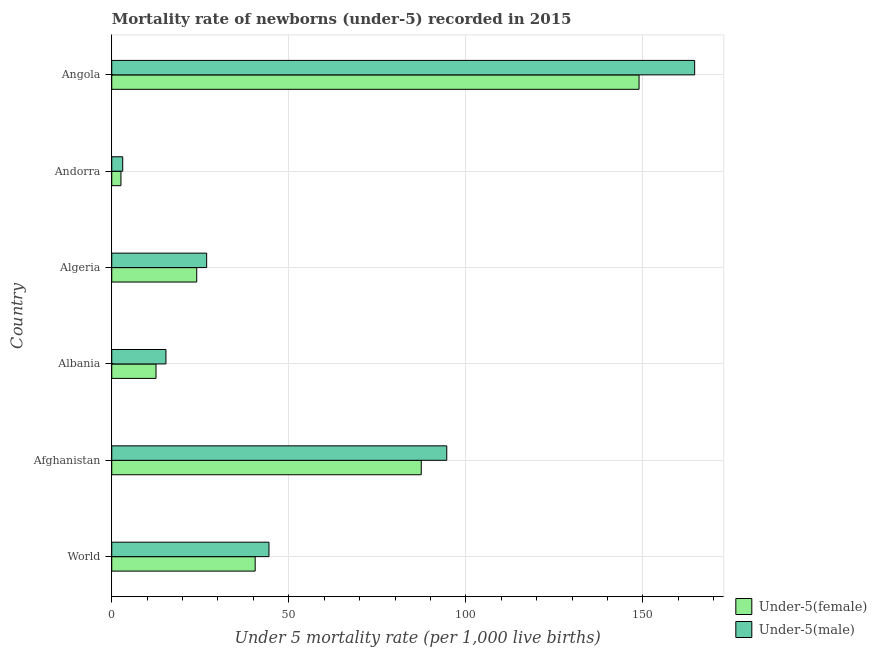Are the number of bars per tick equal to the number of legend labels?
Provide a short and direct response. Yes. Are the number of bars on each tick of the Y-axis equal?
Make the answer very short. Yes. What is the label of the 1st group of bars from the top?
Keep it short and to the point. Angola. Across all countries, what is the maximum under-5 male mortality rate?
Your response must be concise. 164.6. Across all countries, what is the minimum under-5 female mortality rate?
Your response must be concise. 2.6. In which country was the under-5 female mortality rate maximum?
Give a very brief answer. Angola. In which country was the under-5 male mortality rate minimum?
Offer a very short reply. Andorra. What is the total under-5 female mortality rate in the graph?
Give a very brief answer. 315.9. What is the difference between the under-5 female mortality rate in Afghanistan and that in Algeria?
Provide a short and direct response. 63.4. What is the difference between the under-5 male mortality rate in Andorra and the under-5 female mortality rate in Albania?
Your response must be concise. -9.4. What is the average under-5 male mortality rate per country?
Offer a very short reply. 58.13. What is the difference between the under-5 female mortality rate and under-5 male mortality rate in Angola?
Your answer should be very brief. -15.7. In how many countries, is the under-5 female mortality rate greater than 20 ?
Give a very brief answer. 4. What is the ratio of the under-5 male mortality rate in Albania to that in Angola?
Offer a terse response. 0.09. What is the difference between the highest and the second highest under-5 female mortality rate?
Make the answer very short. 61.5. What is the difference between the highest and the lowest under-5 female mortality rate?
Your answer should be compact. 146.3. What does the 1st bar from the top in Angola represents?
Your response must be concise. Under-5(male). What does the 2nd bar from the bottom in Afghanistan represents?
Keep it short and to the point. Under-5(male). Are the values on the major ticks of X-axis written in scientific E-notation?
Your response must be concise. No. Does the graph contain any zero values?
Make the answer very short. No. Does the graph contain grids?
Give a very brief answer. Yes. Where does the legend appear in the graph?
Offer a terse response. Bottom right. How are the legend labels stacked?
Keep it short and to the point. Vertical. What is the title of the graph?
Provide a succinct answer. Mortality rate of newborns (under-5) recorded in 2015. Does "Investment" appear as one of the legend labels in the graph?
Give a very brief answer. No. What is the label or title of the X-axis?
Keep it short and to the point. Under 5 mortality rate (per 1,0 live births). What is the Under 5 mortality rate (per 1,000 live births) in Under-5(female) in World?
Your answer should be very brief. 40.5. What is the Under 5 mortality rate (per 1,000 live births) in Under-5(male) in World?
Make the answer very short. 44.4. What is the Under 5 mortality rate (per 1,000 live births) of Under-5(female) in Afghanistan?
Provide a succinct answer. 87.4. What is the Under 5 mortality rate (per 1,000 live births) of Under-5(male) in Afghanistan?
Ensure brevity in your answer.  94.6. What is the Under 5 mortality rate (per 1,000 live births) of Under-5(female) in Algeria?
Your answer should be compact. 24. What is the Under 5 mortality rate (per 1,000 live births) of Under-5(male) in Algeria?
Your response must be concise. 26.8. What is the Under 5 mortality rate (per 1,000 live births) in Under-5(female) in Andorra?
Make the answer very short. 2.6. What is the Under 5 mortality rate (per 1,000 live births) in Under-5(male) in Andorra?
Give a very brief answer. 3.1. What is the Under 5 mortality rate (per 1,000 live births) of Under-5(female) in Angola?
Your answer should be compact. 148.9. What is the Under 5 mortality rate (per 1,000 live births) of Under-5(male) in Angola?
Make the answer very short. 164.6. Across all countries, what is the maximum Under 5 mortality rate (per 1,000 live births) of Under-5(female)?
Your answer should be very brief. 148.9. Across all countries, what is the maximum Under 5 mortality rate (per 1,000 live births) in Under-5(male)?
Your answer should be very brief. 164.6. Across all countries, what is the minimum Under 5 mortality rate (per 1,000 live births) of Under-5(female)?
Provide a short and direct response. 2.6. What is the total Under 5 mortality rate (per 1,000 live births) of Under-5(female) in the graph?
Make the answer very short. 315.9. What is the total Under 5 mortality rate (per 1,000 live births) in Under-5(male) in the graph?
Provide a short and direct response. 348.8. What is the difference between the Under 5 mortality rate (per 1,000 live births) of Under-5(female) in World and that in Afghanistan?
Give a very brief answer. -46.9. What is the difference between the Under 5 mortality rate (per 1,000 live births) in Under-5(male) in World and that in Afghanistan?
Make the answer very short. -50.2. What is the difference between the Under 5 mortality rate (per 1,000 live births) of Under-5(female) in World and that in Albania?
Ensure brevity in your answer.  28. What is the difference between the Under 5 mortality rate (per 1,000 live births) in Under-5(male) in World and that in Albania?
Your response must be concise. 29.1. What is the difference between the Under 5 mortality rate (per 1,000 live births) of Under-5(female) in World and that in Andorra?
Give a very brief answer. 37.9. What is the difference between the Under 5 mortality rate (per 1,000 live births) of Under-5(male) in World and that in Andorra?
Offer a very short reply. 41.3. What is the difference between the Under 5 mortality rate (per 1,000 live births) of Under-5(female) in World and that in Angola?
Offer a terse response. -108.4. What is the difference between the Under 5 mortality rate (per 1,000 live births) of Under-5(male) in World and that in Angola?
Keep it short and to the point. -120.2. What is the difference between the Under 5 mortality rate (per 1,000 live births) of Under-5(female) in Afghanistan and that in Albania?
Provide a short and direct response. 74.9. What is the difference between the Under 5 mortality rate (per 1,000 live births) in Under-5(male) in Afghanistan and that in Albania?
Keep it short and to the point. 79.3. What is the difference between the Under 5 mortality rate (per 1,000 live births) in Under-5(female) in Afghanistan and that in Algeria?
Ensure brevity in your answer.  63.4. What is the difference between the Under 5 mortality rate (per 1,000 live births) of Under-5(male) in Afghanistan and that in Algeria?
Provide a succinct answer. 67.8. What is the difference between the Under 5 mortality rate (per 1,000 live births) of Under-5(female) in Afghanistan and that in Andorra?
Offer a very short reply. 84.8. What is the difference between the Under 5 mortality rate (per 1,000 live births) in Under-5(male) in Afghanistan and that in Andorra?
Provide a short and direct response. 91.5. What is the difference between the Under 5 mortality rate (per 1,000 live births) in Under-5(female) in Afghanistan and that in Angola?
Give a very brief answer. -61.5. What is the difference between the Under 5 mortality rate (per 1,000 live births) of Under-5(male) in Afghanistan and that in Angola?
Your answer should be compact. -70. What is the difference between the Under 5 mortality rate (per 1,000 live births) of Under-5(female) in Albania and that in Andorra?
Your answer should be very brief. 9.9. What is the difference between the Under 5 mortality rate (per 1,000 live births) of Under-5(male) in Albania and that in Andorra?
Ensure brevity in your answer.  12.2. What is the difference between the Under 5 mortality rate (per 1,000 live births) in Under-5(female) in Albania and that in Angola?
Provide a succinct answer. -136.4. What is the difference between the Under 5 mortality rate (per 1,000 live births) of Under-5(male) in Albania and that in Angola?
Give a very brief answer. -149.3. What is the difference between the Under 5 mortality rate (per 1,000 live births) of Under-5(female) in Algeria and that in Andorra?
Your answer should be compact. 21.4. What is the difference between the Under 5 mortality rate (per 1,000 live births) of Under-5(male) in Algeria and that in Andorra?
Provide a succinct answer. 23.7. What is the difference between the Under 5 mortality rate (per 1,000 live births) in Under-5(female) in Algeria and that in Angola?
Your answer should be very brief. -124.9. What is the difference between the Under 5 mortality rate (per 1,000 live births) in Under-5(male) in Algeria and that in Angola?
Give a very brief answer. -137.8. What is the difference between the Under 5 mortality rate (per 1,000 live births) in Under-5(female) in Andorra and that in Angola?
Provide a short and direct response. -146.3. What is the difference between the Under 5 mortality rate (per 1,000 live births) in Under-5(male) in Andorra and that in Angola?
Give a very brief answer. -161.5. What is the difference between the Under 5 mortality rate (per 1,000 live births) in Under-5(female) in World and the Under 5 mortality rate (per 1,000 live births) in Under-5(male) in Afghanistan?
Your response must be concise. -54.1. What is the difference between the Under 5 mortality rate (per 1,000 live births) in Under-5(female) in World and the Under 5 mortality rate (per 1,000 live births) in Under-5(male) in Albania?
Keep it short and to the point. 25.2. What is the difference between the Under 5 mortality rate (per 1,000 live births) in Under-5(female) in World and the Under 5 mortality rate (per 1,000 live births) in Under-5(male) in Algeria?
Make the answer very short. 13.7. What is the difference between the Under 5 mortality rate (per 1,000 live births) in Under-5(female) in World and the Under 5 mortality rate (per 1,000 live births) in Under-5(male) in Andorra?
Provide a succinct answer. 37.4. What is the difference between the Under 5 mortality rate (per 1,000 live births) in Under-5(female) in World and the Under 5 mortality rate (per 1,000 live births) in Under-5(male) in Angola?
Provide a succinct answer. -124.1. What is the difference between the Under 5 mortality rate (per 1,000 live births) in Under-5(female) in Afghanistan and the Under 5 mortality rate (per 1,000 live births) in Under-5(male) in Albania?
Keep it short and to the point. 72.1. What is the difference between the Under 5 mortality rate (per 1,000 live births) of Under-5(female) in Afghanistan and the Under 5 mortality rate (per 1,000 live births) of Under-5(male) in Algeria?
Provide a succinct answer. 60.6. What is the difference between the Under 5 mortality rate (per 1,000 live births) in Under-5(female) in Afghanistan and the Under 5 mortality rate (per 1,000 live births) in Under-5(male) in Andorra?
Ensure brevity in your answer.  84.3. What is the difference between the Under 5 mortality rate (per 1,000 live births) of Under-5(female) in Afghanistan and the Under 5 mortality rate (per 1,000 live births) of Under-5(male) in Angola?
Give a very brief answer. -77.2. What is the difference between the Under 5 mortality rate (per 1,000 live births) in Under-5(female) in Albania and the Under 5 mortality rate (per 1,000 live births) in Under-5(male) in Algeria?
Your response must be concise. -14.3. What is the difference between the Under 5 mortality rate (per 1,000 live births) in Under-5(female) in Albania and the Under 5 mortality rate (per 1,000 live births) in Under-5(male) in Angola?
Your answer should be very brief. -152.1. What is the difference between the Under 5 mortality rate (per 1,000 live births) of Under-5(female) in Algeria and the Under 5 mortality rate (per 1,000 live births) of Under-5(male) in Andorra?
Provide a succinct answer. 20.9. What is the difference between the Under 5 mortality rate (per 1,000 live births) of Under-5(female) in Algeria and the Under 5 mortality rate (per 1,000 live births) of Under-5(male) in Angola?
Your response must be concise. -140.6. What is the difference between the Under 5 mortality rate (per 1,000 live births) of Under-5(female) in Andorra and the Under 5 mortality rate (per 1,000 live births) of Under-5(male) in Angola?
Give a very brief answer. -162. What is the average Under 5 mortality rate (per 1,000 live births) of Under-5(female) per country?
Offer a very short reply. 52.65. What is the average Under 5 mortality rate (per 1,000 live births) of Under-5(male) per country?
Make the answer very short. 58.13. What is the difference between the Under 5 mortality rate (per 1,000 live births) in Under-5(female) and Under 5 mortality rate (per 1,000 live births) in Under-5(male) in World?
Offer a very short reply. -3.9. What is the difference between the Under 5 mortality rate (per 1,000 live births) of Under-5(female) and Under 5 mortality rate (per 1,000 live births) of Under-5(male) in Afghanistan?
Offer a very short reply. -7.2. What is the difference between the Under 5 mortality rate (per 1,000 live births) of Under-5(female) and Under 5 mortality rate (per 1,000 live births) of Under-5(male) in Algeria?
Make the answer very short. -2.8. What is the difference between the Under 5 mortality rate (per 1,000 live births) in Under-5(female) and Under 5 mortality rate (per 1,000 live births) in Under-5(male) in Angola?
Your response must be concise. -15.7. What is the ratio of the Under 5 mortality rate (per 1,000 live births) in Under-5(female) in World to that in Afghanistan?
Keep it short and to the point. 0.46. What is the ratio of the Under 5 mortality rate (per 1,000 live births) of Under-5(male) in World to that in Afghanistan?
Offer a terse response. 0.47. What is the ratio of the Under 5 mortality rate (per 1,000 live births) in Under-5(female) in World to that in Albania?
Your answer should be very brief. 3.24. What is the ratio of the Under 5 mortality rate (per 1,000 live births) of Under-5(male) in World to that in Albania?
Offer a very short reply. 2.9. What is the ratio of the Under 5 mortality rate (per 1,000 live births) of Under-5(female) in World to that in Algeria?
Provide a short and direct response. 1.69. What is the ratio of the Under 5 mortality rate (per 1,000 live births) in Under-5(male) in World to that in Algeria?
Ensure brevity in your answer.  1.66. What is the ratio of the Under 5 mortality rate (per 1,000 live births) of Under-5(female) in World to that in Andorra?
Your answer should be compact. 15.58. What is the ratio of the Under 5 mortality rate (per 1,000 live births) of Under-5(male) in World to that in Andorra?
Ensure brevity in your answer.  14.32. What is the ratio of the Under 5 mortality rate (per 1,000 live births) in Under-5(female) in World to that in Angola?
Offer a very short reply. 0.27. What is the ratio of the Under 5 mortality rate (per 1,000 live births) in Under-5(male) in World to that in Angola?
Offer a very short reply. 0.27. What is the ratio of the Under 5 mortality rate (per 1,000 live births) in Under-5(female) in Afghanistan to that in Albania?
Your answer should be compact. 6.99. What is the ratio of the Under 5 mortality rate (per 1,000 live births) in Under-5(male) in Afghanistan to that in Albania?
Make the answer very short. 6.18. What is the ratio of the Under 5 mortality rate (per 1,000 live births) in Under-5(female) in Afghanistan to that in Algeria?
Keep it short and to the point. 3.64. What is the ratio of the Under 5 mortality rate (per 1,000 live births) in Under-5(male) in Afghanistan to that in Algeria?
Provide a succinct answer. 3.53. What is the ratio of the Under 5 mortality rate (per 1,000 live births) of Under-5(female) in Afghanistan to that in Andorra?
Give a very brief answer. 33.62. What is the ratio of the Under 5 mortality rate (per 1,000 live births) in Under-5(male) in Afghanistan to that in Andorra?
Offer a terse response. 30.52. What is the ratio of the Under 5 mortality rate (per 1,000 live births) in Under-5(female) in Afghanistan to that in Angola?
Your answer should be very brief. 0.59. What is the ratio of the Under 5 mortality rate (per 1,000 live births) of Under-5(male) in Afghanistan to that in Angola?
Your answer should be compact. 0.57. What is the ratio of the Under 5 mortality rate (per 1,000 live births) in Under-5(female) in Albania to that in Algeria?
Your answer should be compact. 0.52. What is the ratio of the Under 5 mortality rate (per 1,000 live births) in Under-5(male) in Albania to that in Algeria?
Your answer should be compact. 0.57. What is the ratio of the Under 5 mortality rate (per 1,000 live births) in Under-5(female) in Albania to that in Andorra?
Your answer should be compact. 4.81. What is the ratio of the Under 5 mortality rate (per 1,000 live births) of Under-5(male) in Albania to that in Andorra?
Keep it short and to the point. 4.94. What is the ratio of the Under 5 mortality rate (per 1,000 live births) in Under-5(female) in Albania to that in Angola?
Ensure brevity in your answer.  0.08. What is the ratio of the Under 5 mortality rate (per 1,000 live births) of Under-5(male) in Albania to that in Angola?
Your response must be concise. 0.09. What is the ratio of the Under 5 mortality rate (per 1,000 live births) in Under-5(female) in Algeria to that in Andorra?
Make the answer very short. 9.23. What is the ratio of the Under 5 mortality rate (per 1,000 live births) of Under-5(male) in Algeria to that in Andorra?
Provide a succinct answer. 8.65. What is the ratio of the Under 5 mortality rate (per 1,000 live births) of Under-5(female) in Algeria to that in Angola?
Your answer should be compact. 0.16. What is the ratio of the Under 5 mortality rate (per 1,000 live births) of Under-5(male) in Algeria to that in Angola?
Your response must be concise. 0.16. What is the ratio of the Under 5 mortality rate (per 1,000 live births) of Under-5(female) in Andorra to that in Angola?
Offer a terse response. 0.02. What is the ratio of the Under 5 mortality rate (per 1,000 live births) in Under-5(male) in Andorra to that in Angola?
Ensure brevity in your answer.  0.02. What is the difference between the highest and the second highest Under 5 mortality rate (per 1,000 live births) in Under-5(female)?
Offer a terse response. 61.5. What is the difference between the highest and the second highest Under 5 mortality rate (per 1,000 live births) in Under-5(male)?
Provide a succinct answer. 70. What is the difference between the highest and the lowest Under 5 mortality rate (per 1,000 live births) in Under-5(female)?
Provide a succinct answer. 146.3. What is the difference between the highest and the lowest Under 5 mortality rate (per 1,000 live births) in Under-5(male)?
Your answer should be compact. 161.5. 